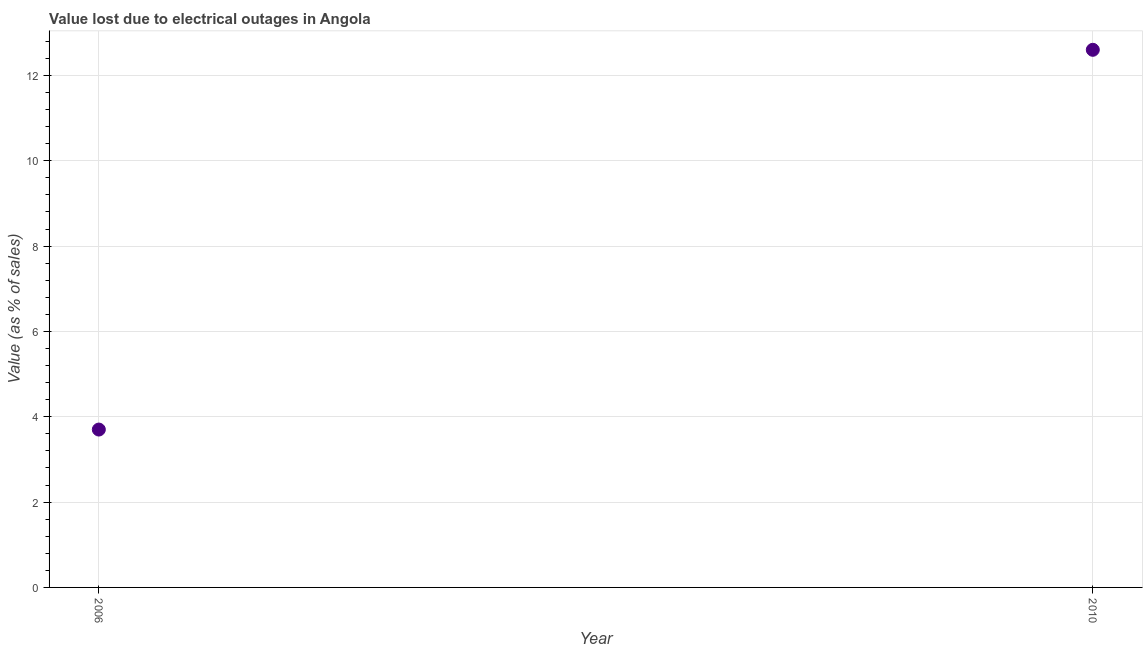What is the value lost due to electrical outages in 2010?
Offer a terse response. 12.6. Across all years, what is the maximum value lost due to electrical outages?
Your response must be concise. 12.6. In which year was the value lost due to electrical outages maximum?
Offer a terse response. 2010. What is the difference between the value lost due to electrical outages in 2006 and 2010?
Offer a very short reply. -8.9. What is the average value lost due to electrical outages per year?
Your response must be concise. 8.15. What is the median value lost due to electrical outages?
Make the answer very short. 8.15. In how many years, is the value lost due to electrical outages greater than 9.2 %?
Keep it short and to the point. 1. What is the ratio of the value lost due to electrical outages in 2006 to that in 2010?
Give a very brief answer. 0.29. Is the value lost due to electrical outages in 2006 less than that in 2010?
Keep it short and to the point. Yes. Are the values on the major ticks of Y-axis written in scientific E-notation?
Give a very brief answer. No. What is the title of the graph?
Ensure brevity in your answer.  Value lost due to electrical outages in Angola. What is the label or title of the X-axis?
Your answer should be compact. Year. What is the label or title of the Y-axis?
Your answer should be very brief. Value (as % of sales). What is the ratio of the Value (as % of sales) in 2006 to that in 2010?
Provide a succinct answer. 0.29. 